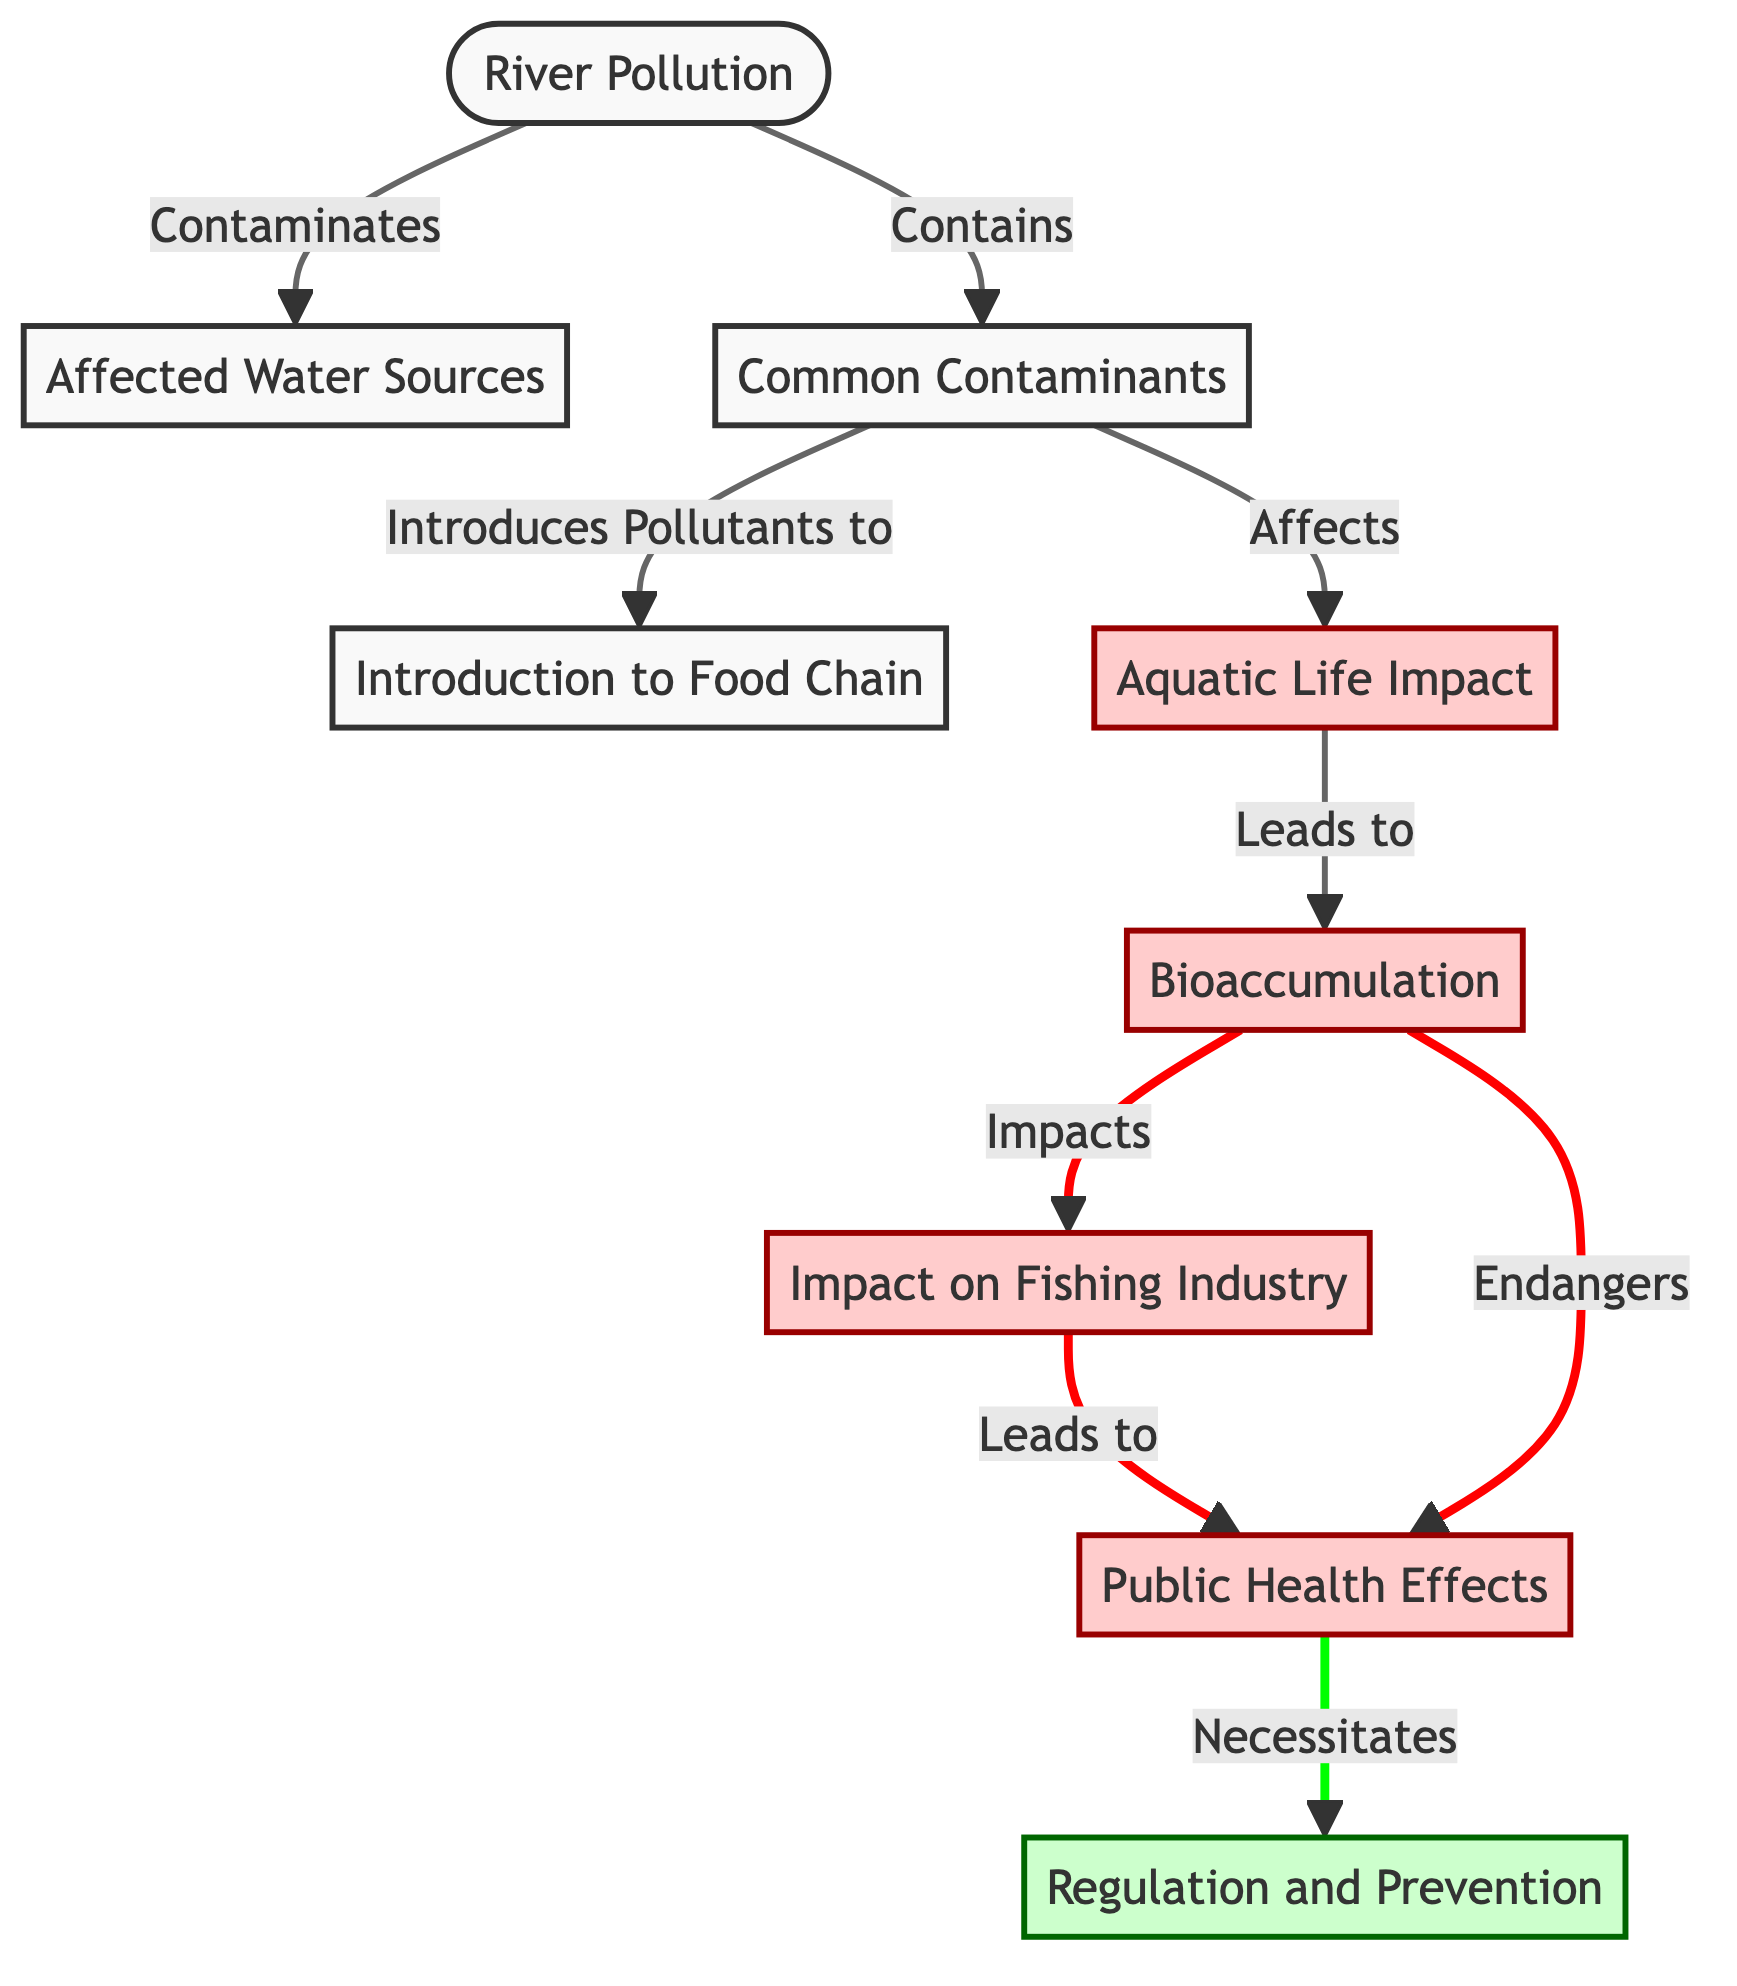What is the primary source of contamination in this diagram? The primary source of contamination is indicated as "River Pollution," which is the starting point of the flow in the diagram, linking to various other elements.
Answer: River Pollution How many nodes are related to public health effects? From the diagram, it can be counted that there are two nodes specifically related to public health effects: "Human Health" and "Bioaccumulation," both of which mention impacts on public health.
Answer: 2 What type of contaminants affect aquatic life according to the diagram? The diagram signifies that "Common Contaminants" affect "Aquatic Life," demonstrating the direct impact of these substances on living organisms in the water.
Answer: Common Contaminants What follows bioaccumulation in the diagram? Following from the node labeled "Bioaccumulation," the next node indicates its impact on the "Fishing Industry," showing a sequential consequence of pollution.
Answer: Impact on Fishing Industry What necessitates regulation according to the diagram? The flow of information indicates that the negative effects on "Human Health" directly lead to the necessity for "Regulation and Prevention," depicting a causal relationship.
Answer: Human Health How does water pollution affect the food chain? Water pollution introduces pollutants into the food chain, specifically indicated in the path from "Contaminants" to "Introduction to Food Chain," creating an entry point for toxins.
Answer: Introduces Pollutants to Food Chain Which component shows the endangerment of human health? The node labeled "Bioaccumulation" explicitly mentions that it endangers "Human Health," highlighting the critical risks involved.
Answer: Endangers Human Health What is an effect of fish industry impacts? The diagram illustrates that the impact on the fishing industry eventually leads to an effect on "Human Health," establishing a clear link between these elements.
Answer: Leads to Human Health 